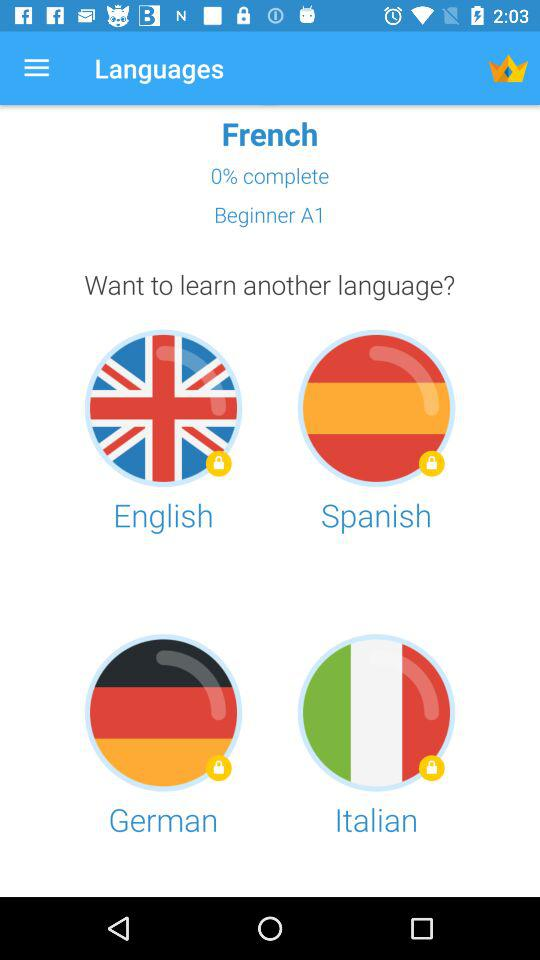What is the current level of the course? The current level of the course is Beginner A1. 